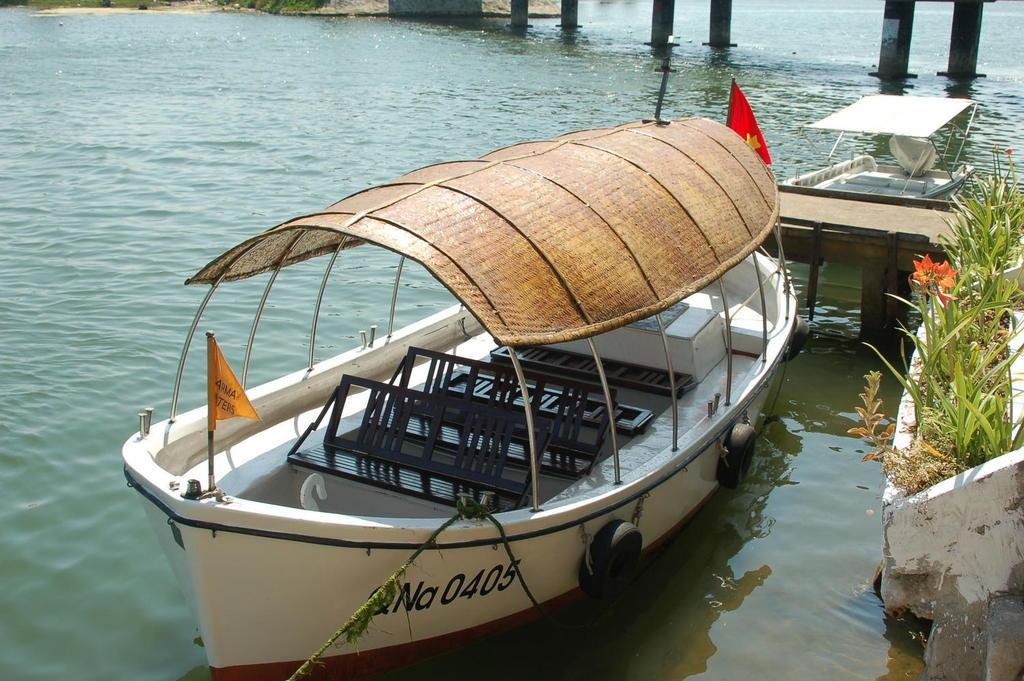What is in the water in the image? There are boats in the water in the image. What can be seen flying or waving in the image? There is a flag visible in the image. What type of vegetation is on the right side of the image? There are plants on the right side of the image. What type of building is visible in the image? There is no building present in the image; it features boats in the water and a flag. What kind of company is represented by the flag in the image? There is no company mentioned or represented in the image; it only shows a flag. 